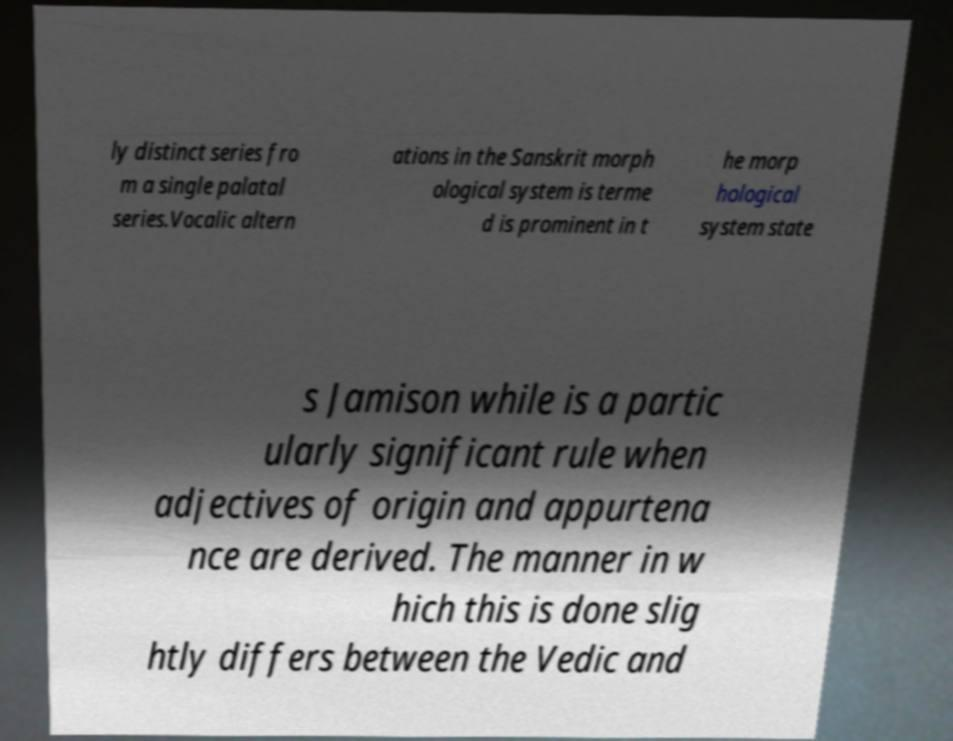Can you read and provide the text displayed in the image?This photo seems to have some interesting text. Can you extract and type it out for me? ly distinct series fro m a single palatal series.Vocalic altern ations in the Sanskrit morph ological system is terme d is prominent in t he morp hological system state s Jamison while is a partic ularly significant rule when adjectives of origin and appurtena nce are derived. The manner in w hich this is done slig htly differs between the Vedic and 